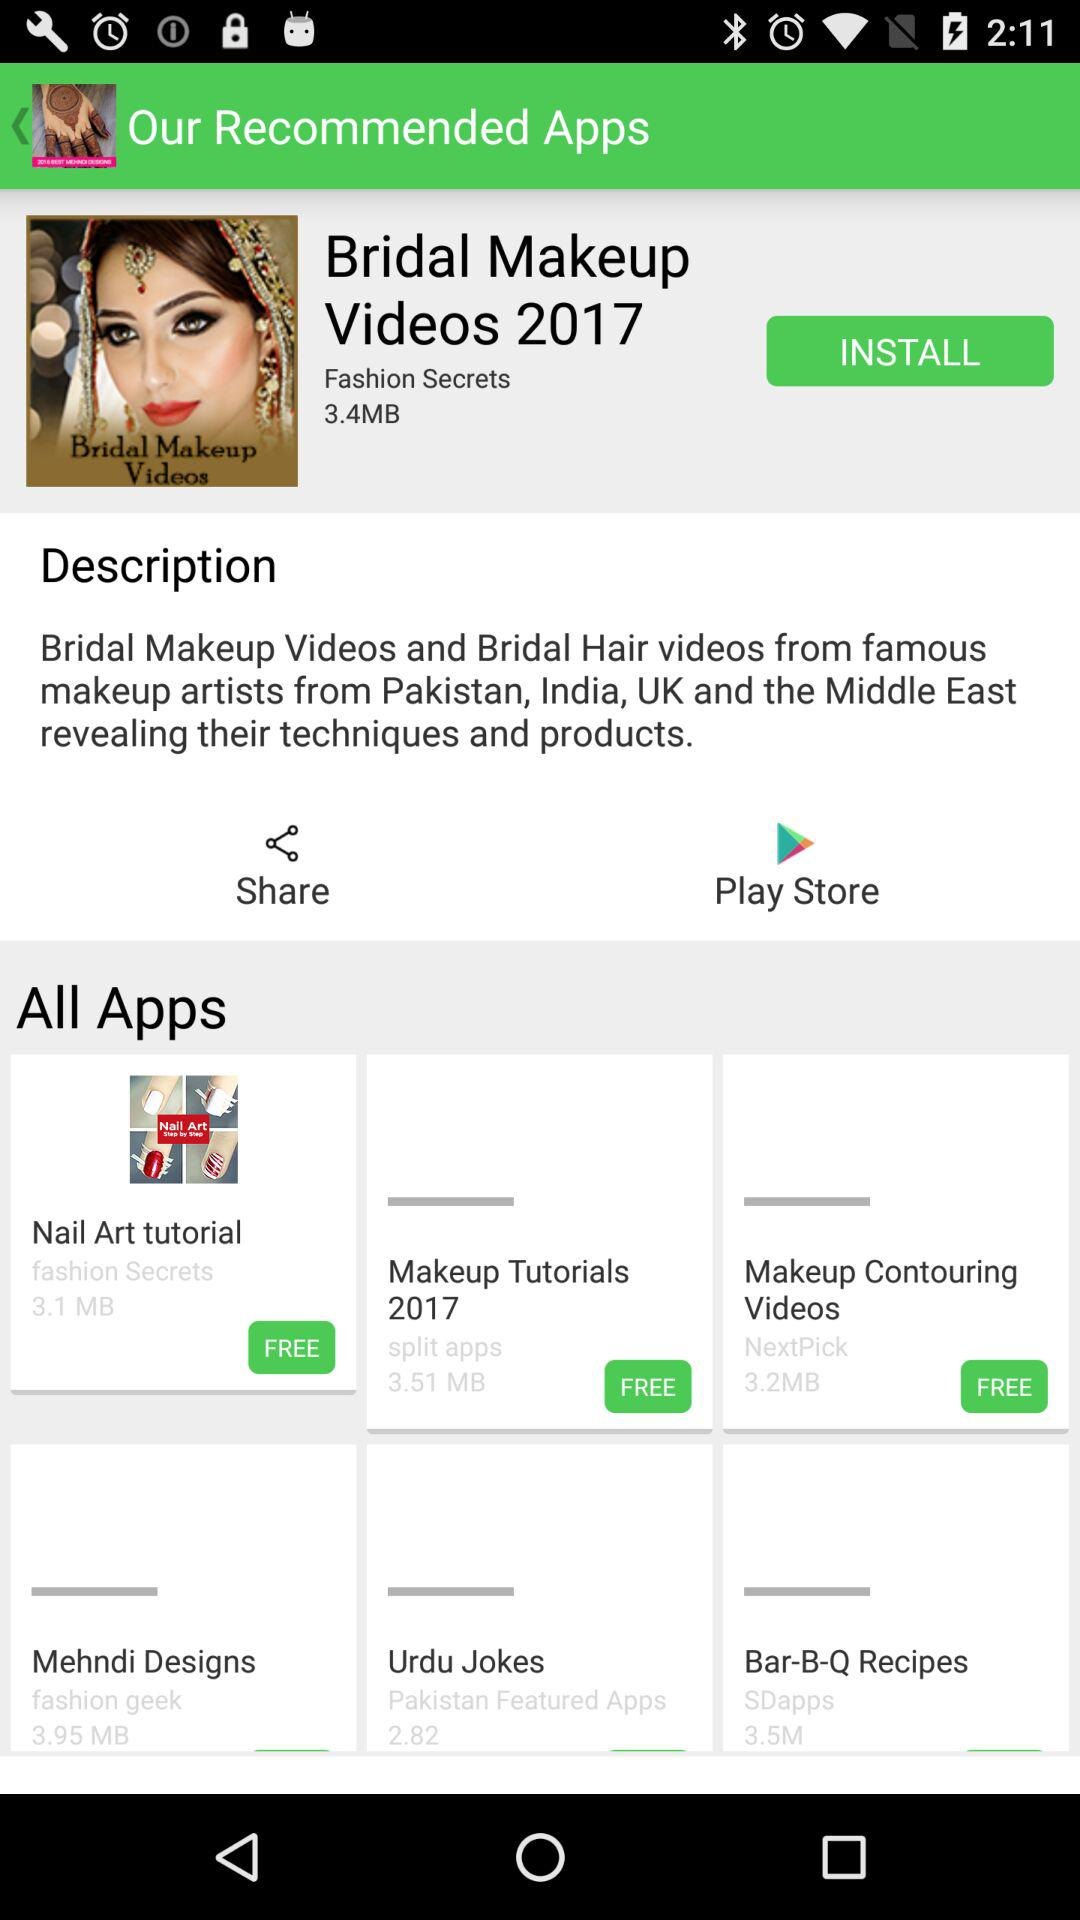What application has a size of 3.95 MB? The application is "Mehndi Designs". 